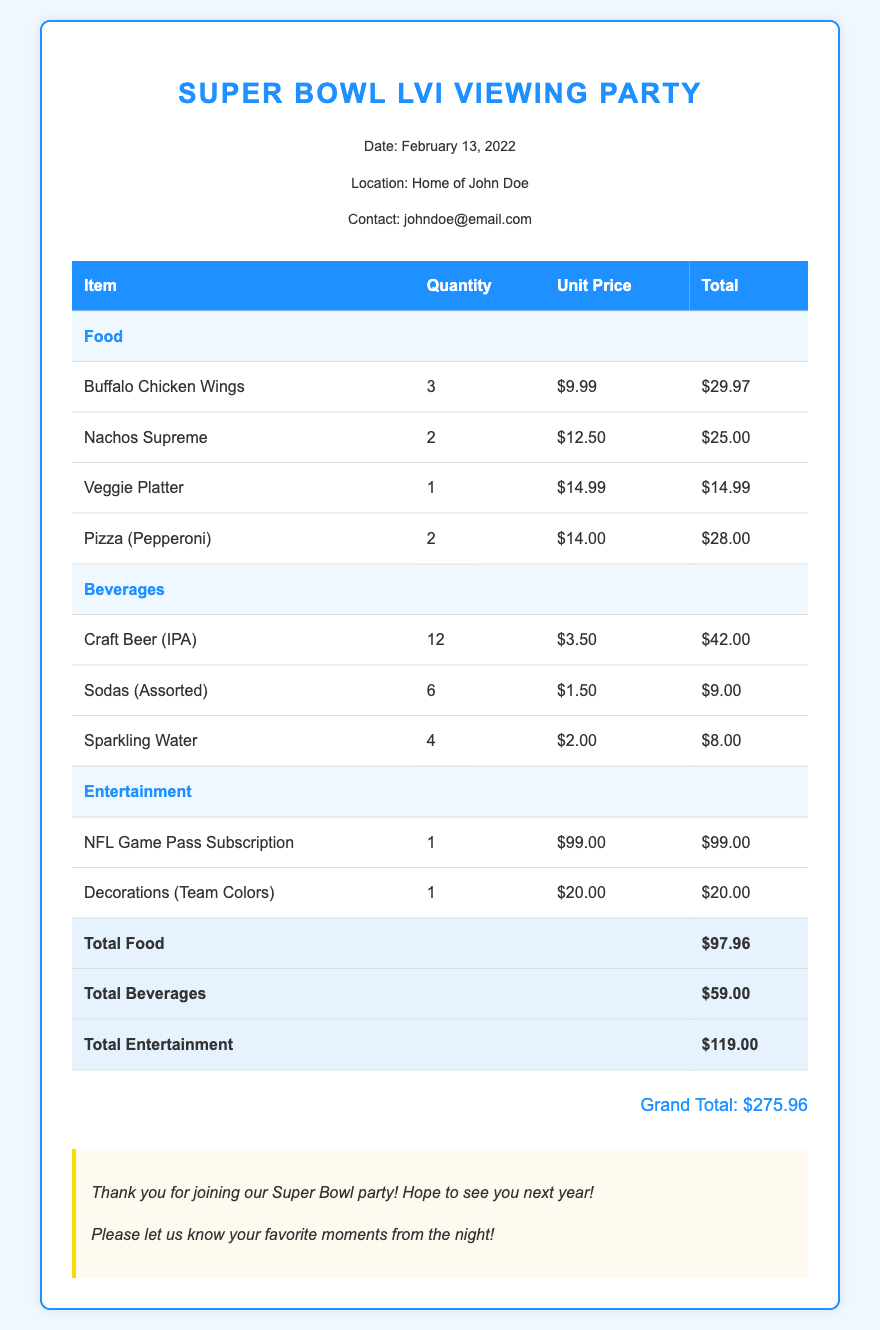What is the date of the Super Bowl LVI Viewing Party? The date is specified in the header info of the document.
Answer: February 13, 2022 Who hosted the Super Bowl LVI Viewing Party? The host's name is mentioned in the header info section of the document.
Answer: John Doe What is the total cost for food? The total cost for food is provided in the table under the total food row.
Answer: $97.96 How many Buffalo Chicken Wings were ordered? The quantity for Buffalo Chicken Wings is specified in the food items section of the table.
Answer: 3 What is the unit price for Craft Beer (IPA)? The unit price for Craft Beer is listed in the beverages section of the table.
Answer: $3.50 What is the Grand Total for the party? The Grand Total is provided at the bottom of the document after all itemized costs.
Answer: $275.96 What type of entertainment was included in the bill? The entertainment section lists the specific items included, which requires understanding the document's context.
Answer: NFL Game Pass Subscription, Decorations How many varieties of beverages were listed? The document specifies the different beverage items in the beverages section of the table.
Answer: 3 What decorations were purchased for the party? The decorations are detailed in the entertainment section of the document.
Answer: Team Colors 